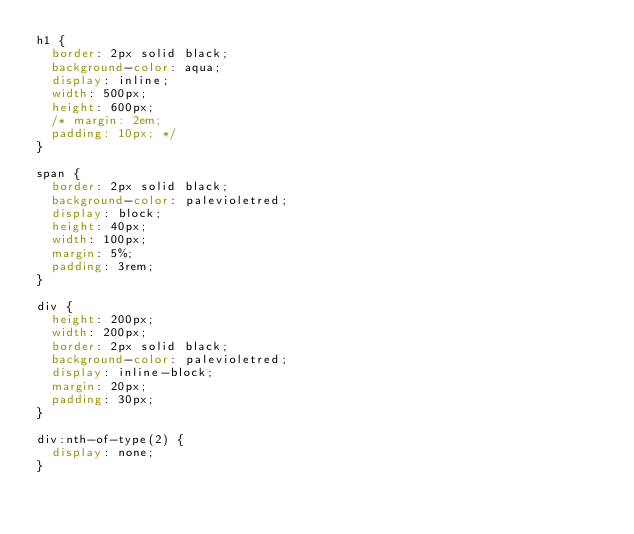Convert code to text. <code><loc_0><loc_0><loc_500><loc_500><_CSS_>h1 {
  border: 2px solid black;
  background-color: aqua;
  display: inline;
  width: 500px;
  height: 600px;
  /* margin: 2em;
  padding: 10px; */
}

span {
  border: 2px solid black;
  background-color: palevioletred;
  display: block;
  height: 40px;
  width: 100px;
  margin: 5%;
  padding: 3rem;
}

div {
  height: 200px;
  width: 200px;
  border: 2px solid black;
  background-color: palevioletred;
  display: inline-block;
  margin: 20px;
  padding: 30px;
}

div:nth-of-type(2) {
  display: none;
}
</code> 